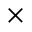Convert formula to latex. <formula><loc_0><loc_0><loc_500><loc_500>\times</formula> 